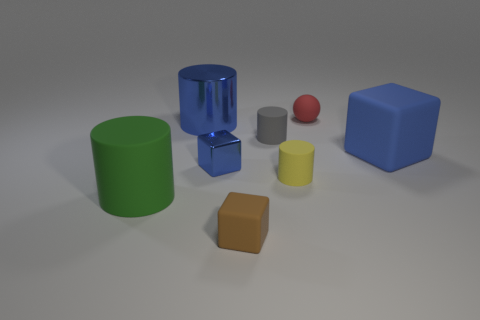Are there fewer small gray things that are on the right side of the tiny yellow object than small yellow matte cylinders that are left of the small red rubber ball?
Your answer should be compact. Yes. Is the gray thing made of the same material as the large blue object that is right of the small rubber sphere?
Offer a terse response. Yes. Are there more tiny brown cubes than matte cubes?
Give a very brief answer. No. What shape is the large object behind the blue thing that is right of the red sphere that is right of the big shiny cylinder?
Make the answer very short. Cylinder. Are the blue cube right of the tiny metallic cube and the object that is behind the large blue shiny thing made of the same material?
Your answer should be compact. Yes. There is a large blue thing that is the same material as the small sphere; what shape is it?
Provide a succinct answer. Cube. Is there any other thing that has the same color as the tiny shiny cube?
Keep it short and to the point. Yes. What number of large brown spheres are there?
Provide a short and direct response. 0. The large blue thing to the left of the tiny red thing behind the brown rubber cube is made of what material?
Offer a terse response. Metal. There is a metal object on the right side of the large cylinder behind the blue thing that is on the right side of the blue metal block; what color is it?
Make the answer very short. Blue. 